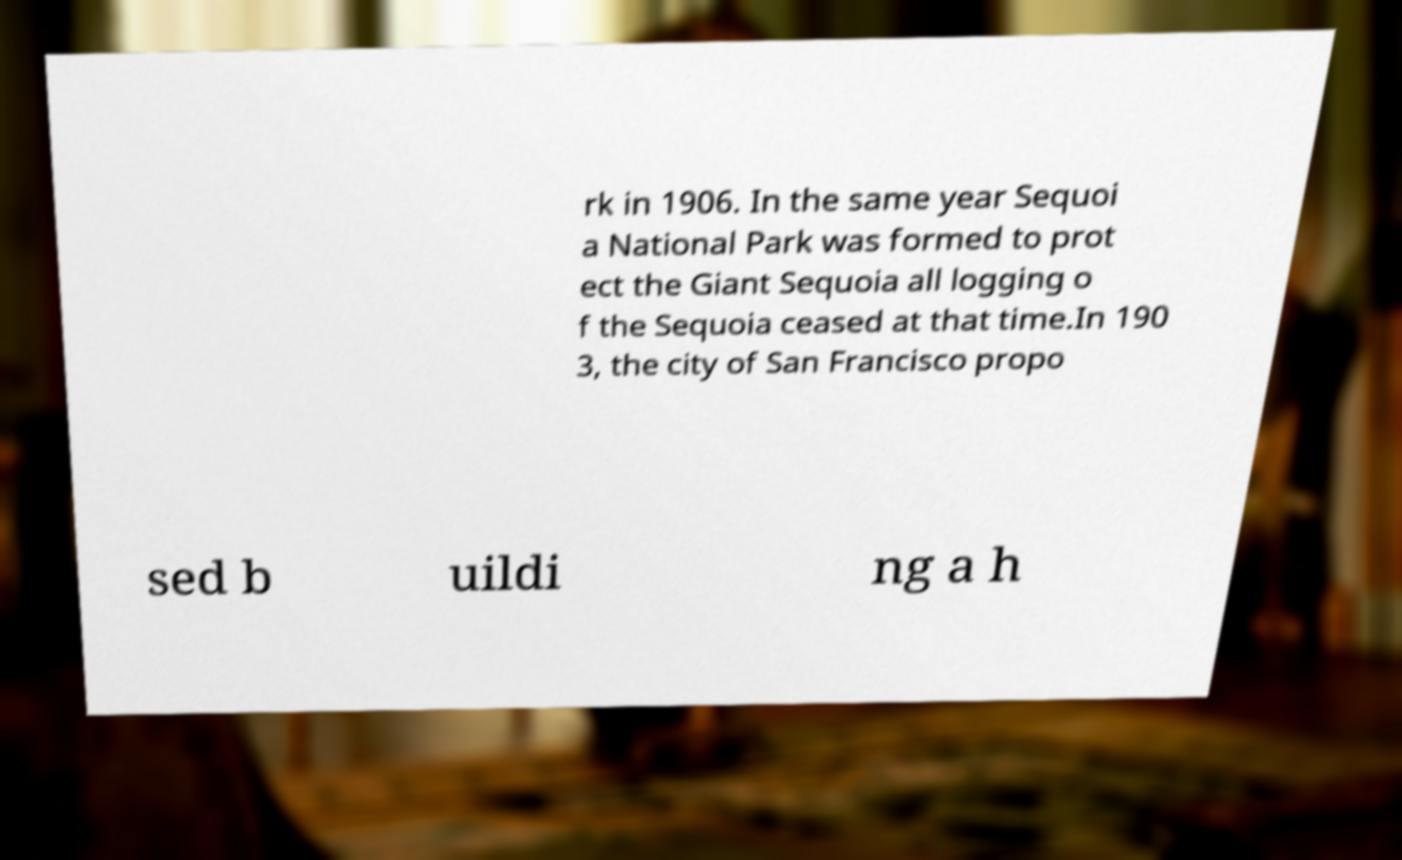Can you read and provide the text displayed in the image?This photo seems to have some interesting text. Can you extract and type it out for me? rk in 1906. In the same year Sequoi a National Park was formed to prot ect the Giant Sequoia all logging o f the Sequoia ceased at that time.In 190 3, the city of San Francisco propo sed b uildi ng a h 